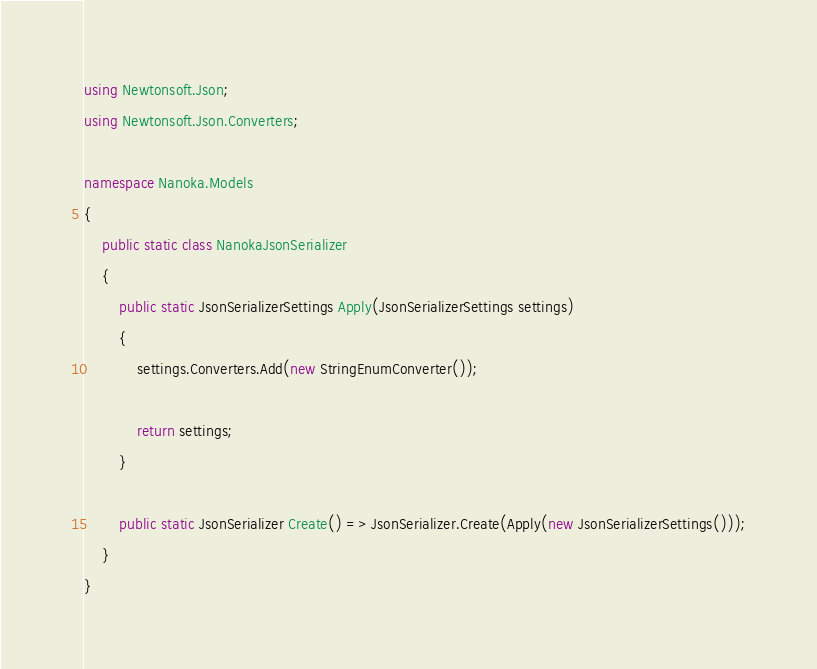<code> <loc_0><loc_0><loc_500><loc_500><_C#_>using Newtonsoft.Json;
using Newtonsoft.Json.Converters;

namespace Nanoka.Models
{
    public static class NanokaJsonSerializer
    {
        public static JsonSerializerSettings Apply(JsonSerializerSettings settings)
        {
            settings.Converters.Add(new StringEnumConverter());

            return settings;
        }

        public static JsonSerializer Create() => JsonSerializer.Create(Apply(new JsonSerializerSettings()));
    }
}</code> 